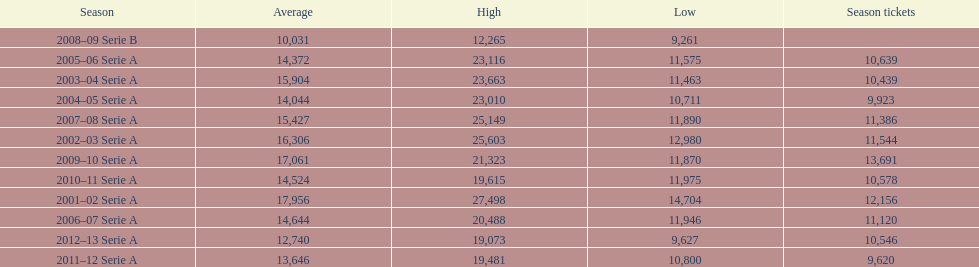What seasons were played at the stadio ennio tardini 2001–02 Serie A, 2002–03 Serie A, 2003–04 Serie A, 2004–05 Serie A, 2005–06 Serie A, 2006–07 Serie A, 2007–08 Serie A, 2008–09 Serie B, 2009–10 Serie A, 2010–11 Serie A, 2011–12 Serie A, 2012–13 Serie A. Which of these seasons had season tickets? 2001–02 Serie A, 2002–03 Serie A, 2003–04 Serie A, 2004–05 Serie A, 2005–06 Serie A, 2006–07 Serie A, 2007–08 Serie A, 2009–10 Serie A, 2010–11 Serie A, 2011–12 Serie A, 2012–13 Serie A. How many season tickets did the 2007-08 season have? 11,386. 